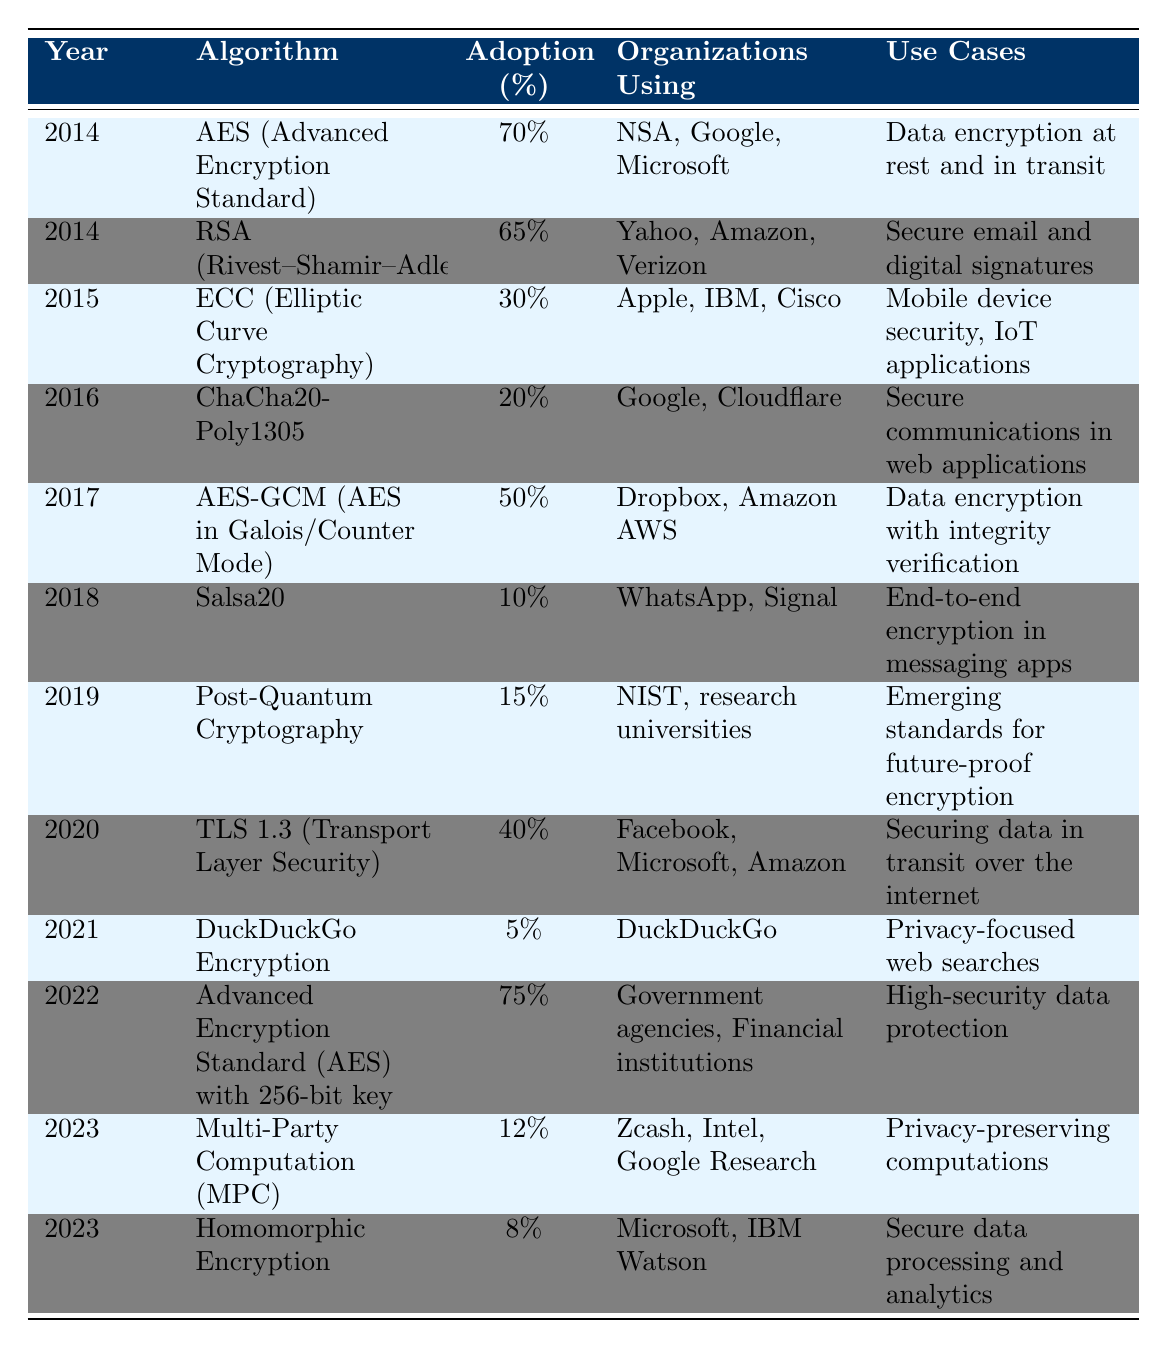What was the adoption percentage of AES in 2014? The table displays the adoption percentage of various algorithms for each year. Looking at the row for 2014 and the algorithm AES, the adoption percentage is listed as 70%.
Answer: 70% Which organization was using RSA in 2014? The table indicates which organizations were using each algorithm in each year. For RSA in 2014, the organizations listed are Yahoo, Amazon, and Verizon.
Answer: Yahoo, Amazon, Verizon What is the adoption percentage of TLS 1.3 in 2020 compared to DuckDuckGo Encryption in 2021? From the table, TLS 1.3's adoption percentage in 2020 is 40% and DuckDuckGo Encryption in 2021 is 5%. To compare them, we can see that TLS 1.3 has a significantly higher adoption at 40%, whereas DuckDuckGo Encryption has a much lower adoption at 5%.
Answer: 40% vs 5% What are the use cases for ChaCha20-Poly1305? The table states the use cases for various algorithms. For ChaCha20-Poly1305, the listed use case is secure communications in web applications.
Answer: Secure communications in web applications What is the average adoption percentage of algorithms in the year 2018 and 2019? To calculate the average, we need the adoption percentages for those years. In 2018, Salsa20 has an adoption of 10%, and in 2019, Post-Quantum Cryptography has an adoption of 15%. The average is (10% + 15%) / 2 = 25% / 2 = 12.5%.
Answer: 12.5% Which algorithm had the highest adoption in 2022? In the year 2022, the algorithm is AES with a 256-bit key, and its adoption percentage is 75%, making it the highest for that year.
Answer: AES with 256-bit key Is it true that Multi-Party Computation had a higher adoption rate than Homomorphic Encryption in 2023? According to the table, Multi-Party Computation had an adoption rate of 12% in 2023, while Homomorphic Encryption had an adoption rate of 8%. Since 12% is greater than 8%, the statement is true.
Answer: Yes What is the trend of adoption for AES from 2014 to 2022? The adoption percentages for AES are 70% in 2014, 75% in 2022. This shows a general upward trend, increasing from 70% to 75% over the years. Hence, there is a positive trend for AES adoption in this period.
Answer: Upward trend Calculate the total adoption percentage for all algorithms in 2020 and 2021. The adoption percentages for those years are 40% for TLS 1.3 in 2020 and 5% for DuckDuckGo Encryption in 2021. Adding them gives 40% + 5% = 45%.
Answer: 45% How many algorithms had an adoption percentage of less than 20% in 2016 and 2018? In 2016, ChaCha20-Poly1305 had an adoption percentage of 20% (not less) and Salsa20 in 2018 had an adoption of 10% (less). So, only one algorithm had an adoption percentage of less than 20% when considering both years combined.
Answer: 1 